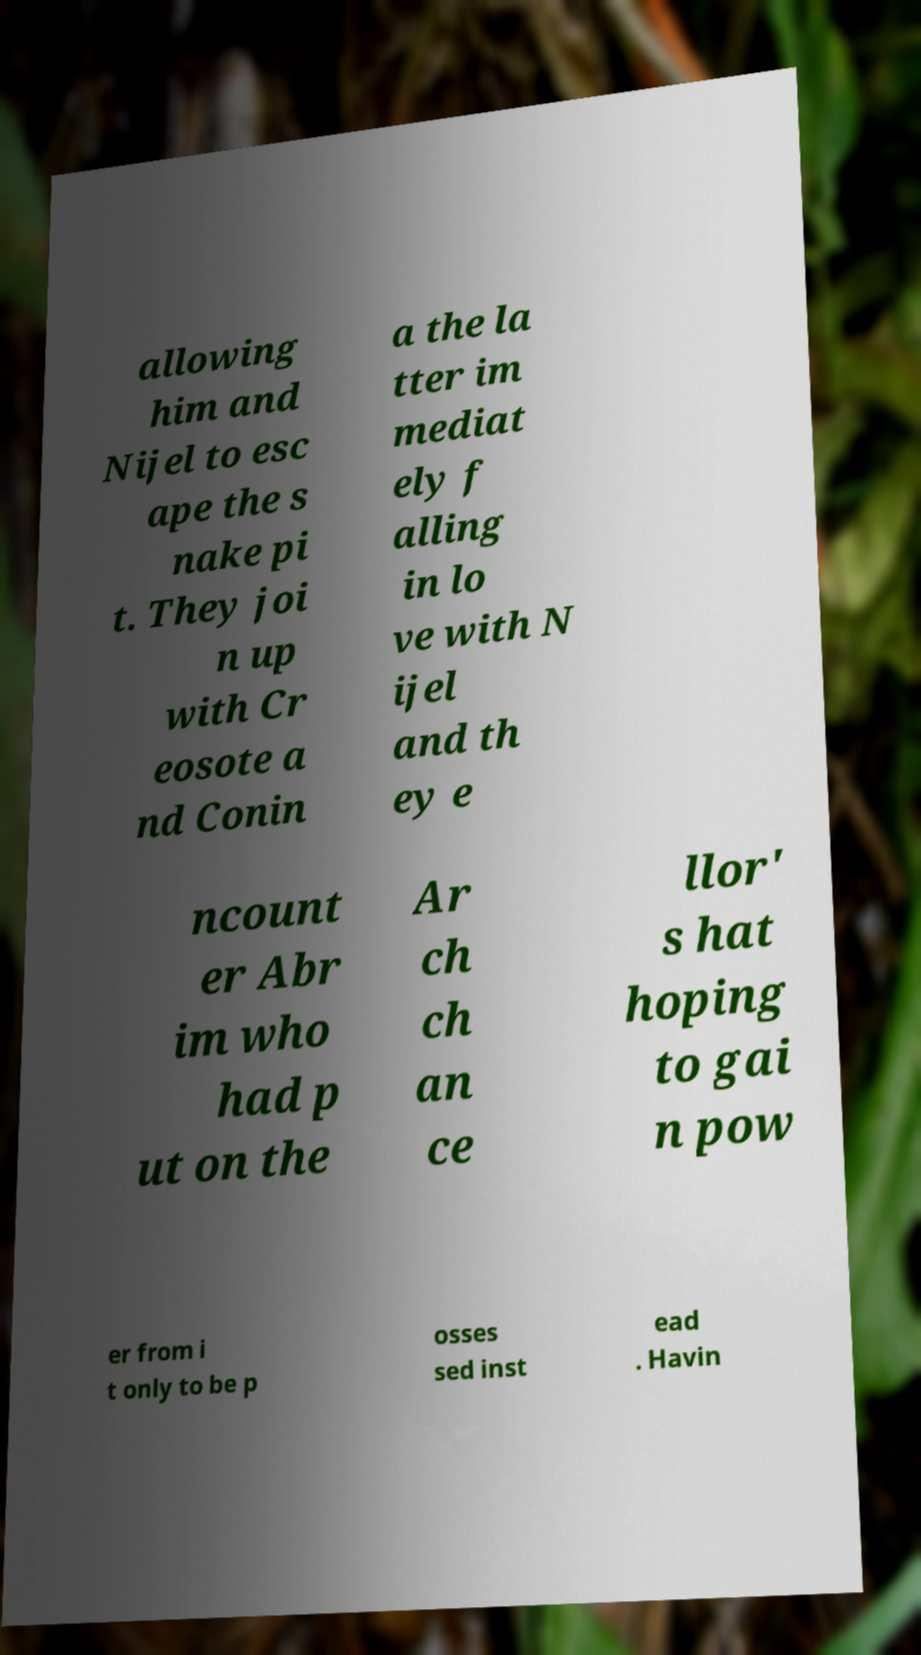Please read and relay the text visible in this image. What does it say? allowing him and Nijel to esc ape the s nake pi t. They joi n up with Cr eosote a nd Conin a the la tter im mediat ely f alling in lo ve with N ijel and th ey e ncount er Abr im who had p ut on the Ar ch ch an ce llor' s hat hoping to gai n pow er from i t only to be p osses sed inst ead . Havin 